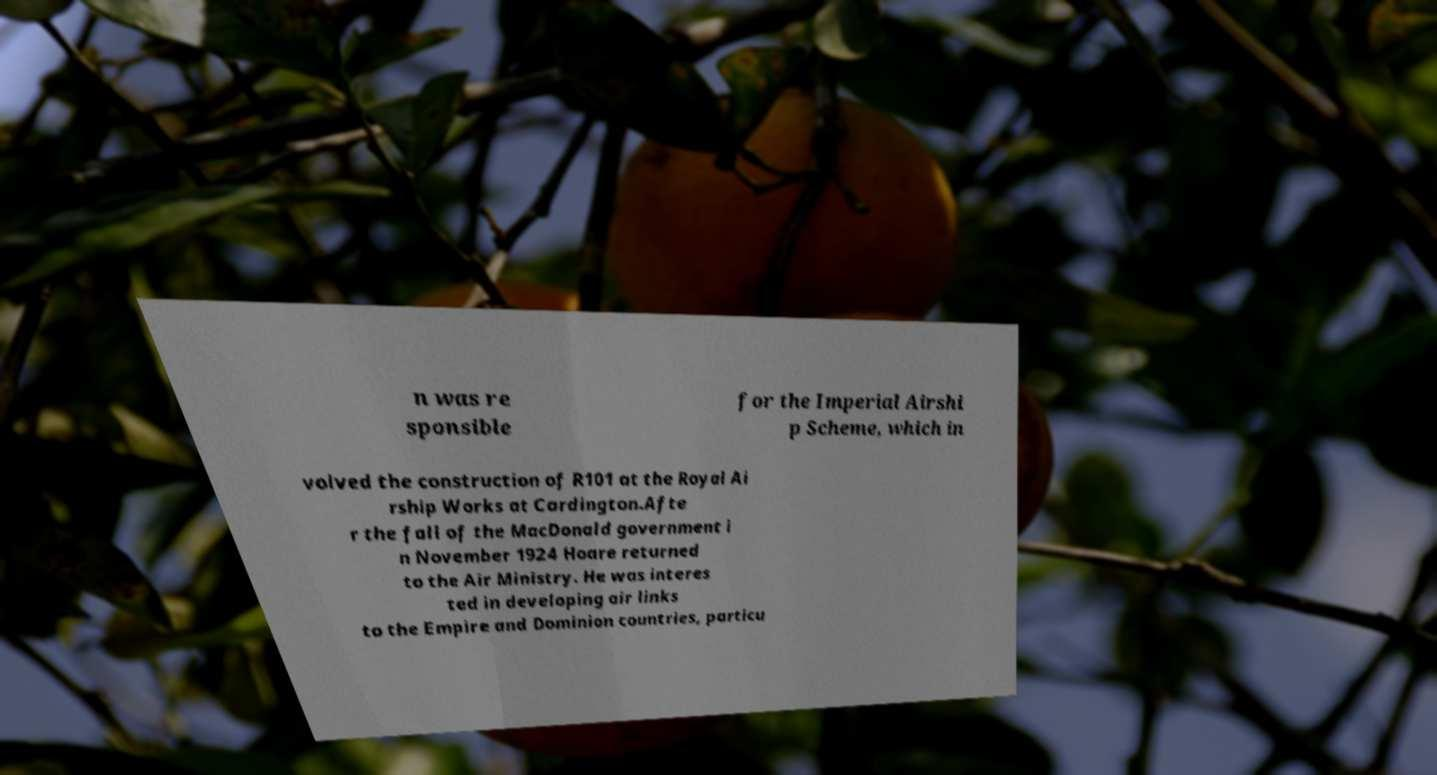There's text embedded in this image that I need extracted. Can you transcribe it verbatim? n was re sponsible for the Imperial Airshi p Scheme, which in volved the construction of R101 at the Royal Ai rship Works at Cardington.Afte r the fall of the MacDonald government i n November 1924 Hoare returned to the Air Ministry. He was interes ted in developing air links to the Empire and Dominion countries, particu 